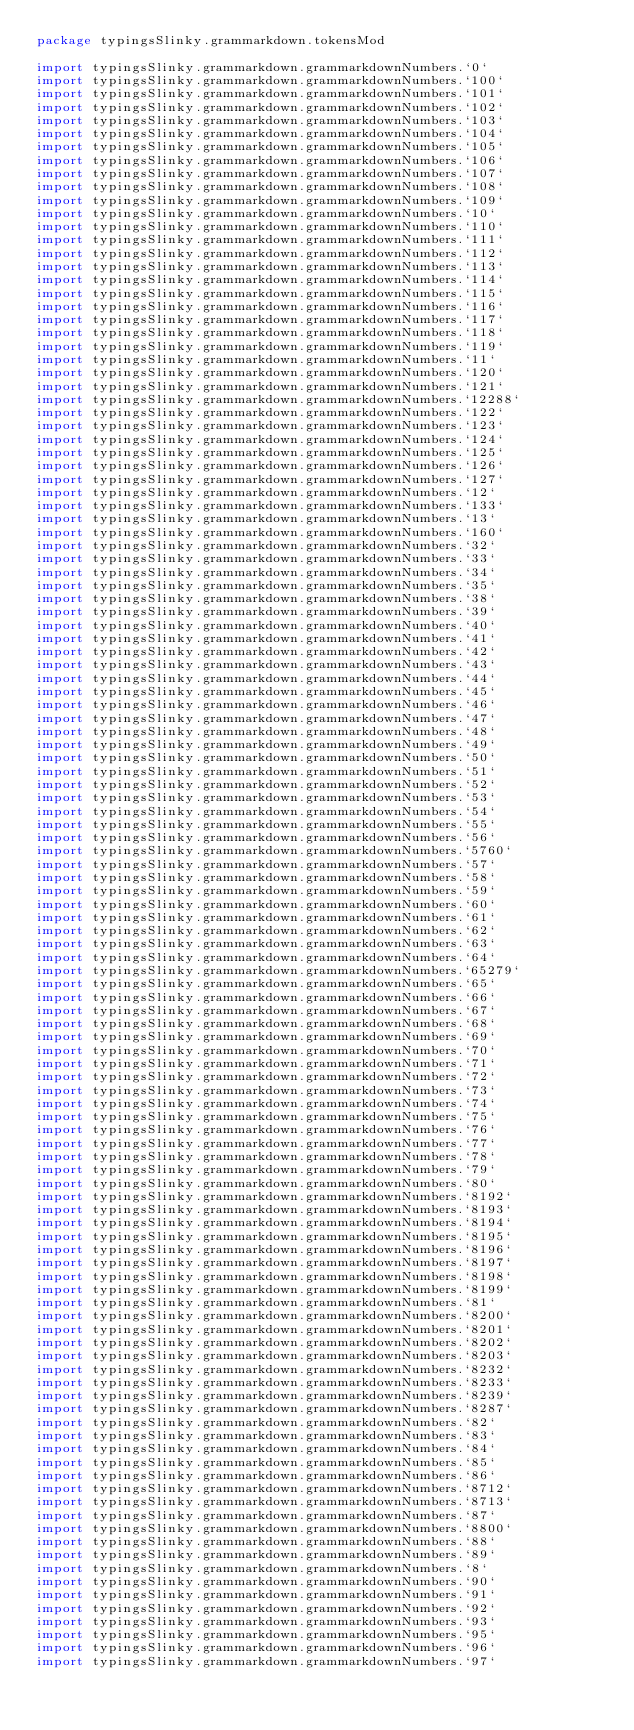<code> <loc_0><loc_0><loc_500><loc_500><_Scala_>package typingsSlinky.grammarkdown.tokensMod

import typingsSlinky.grammarkdown.grammarkdownNumbers.`0`
import typingsSlinky.grammarkdown.grammarkdownNumbers.`100`
import typingsSlinky.grammarkdown.grammarkdownNumbers.`101`
import typingsSlinky.grammarkdown.grammarkdownNumbers.`102`
import typingsSlinky.grammarkdown.grammarkdownNumbers.`103`
import typingsSlinky.grammarkdown.grammarkdownNumbers.`104`
import typingsSlinky.grammarkdown.grammarkdownNumbers.`105`
import typingsSlinky.grammarkdown.grammarkdownNumbers.`106`
import typingsSlinky.grammarkdown.grammarkdownNumbers.`107`
import typingsSlinky.grammarkdown.grammarkdownNumbers.`108`
import typingsSlinky.grammarkdown.grammarkdownNumbers.`109`
import typingsSlinky.grammarkdown.grammarkdownNumbers.`10`
import typingsSlinky.grammarkdown.grammarkdownNumbers.`110`
import typingsSlinky.grammarkdown.grammarkdownNumbers.`111`
import typingsSlinky.grammarkdown.grammarkdownNumbers.`112`
import typingsSlinky.grammarkdown.grammarkdownNumbers.`113`
import typingsSlinky.grammarkdown.grammarkdownNumbers.`114`
import typingsSlinky.grammarkdown.grammarkdownNumbers.`115`
import typingsSlinky.grammarkdown.grammarkdownNumbers.`116`
import typingsSlinky.grammarkdown.grammarkdownNumbers.`117`
import typingsSlinky.grammarkdown.grammarkdownNumbers.`118`
import typingsSlinky.grammarkdown.grammarkdownNumbers.`119`
import typingsSlinky.grammarkdown.grammarkdownNumbers.`11`
import typingsSlinky.grammarkdown.grammarkdownNumbers.`120`
import typingsSlinky.grammarkdown.grammarkdownNumbers.`121`
import typingsSlinky.grammarkdown.grammarkdownNumbers.`12288`
import typingsSlinky.grammarkdown.grammarkdownNumbers.`122`
import typingsSlinky.grammarkdown.grammarkdownNumbers.`123`
import typingsSlinky.grammarkdown.grammarkdownNumbers.`124`
import typingsSlinky.grammarkdown.grammarkdownNumbers.`125`
import typingsSlinky.grammarkdown.grammarkdownNumbers.`126`
import typingsSlinky.grammarkdown.grammarkdownNumbers.`127`
import typingsSlinky.grammarkdown.grammarkdownNumbers.`12`
import typingsSlinky.grammarkdown.grammarkdownNumbers.`133`
import typingsSlinky.grammarkdown.grammarkdownNumbers.`13`
import typingsSlinky.grammarkdown.grammarkdownNumbers.`160`
import typingsSlinky.grammarkdown.grammarkdownNumbers.`32`
import typingsSlinky.grammarkdown.grammarkdownNumbers.`33`
import typingsSlinky.grammarkdown.grammarkdownNumbers.`34`
import typingsSlinky.grammarkdown.grammarkdownNumbers.`35`
import typingsSlinky.grammarkdown.grammarkdownNumbers.`38`
import typingsSlinky.grammarkdown.grammarkdownNumbers.`39`
import typingsSlinky.grammarkdown.grammarkdownNumbers.`40`
import typingsSlinky.grammarkdown.grammarkdownNumbers.`41`
import typingsSlinky.grammarkdown.grammarkdownNumbers.`42`
import typingsSlinky.grammarkdown.grammarkdownNumbers.`43`
import typingsSlinky.grammarkdown.grammarkdownNumbers.`44`
import typingsSlinky.grammarkdown.grammarkdownNumbers.`45`
import typingsSlinky.grammarkdown.grammarkdownNumbers.`46`
import typingsSlinky.grammarkdown.grammarkdownNumbers.`47`
import typingsSlinky.grammarkdown.grammarkdownNumbers.`48`
import typingsSlinky.grammarkdown.grammarkdownNumbers.`49`
import typingsSlinky.grammarkdown.grammarkdownNumbers.`50`
import typingsSlinky.grammarkdown.grammarkdownNumbers.`51`
import typingsSlinky.grammarkdown.grammarkdownNumbers.`52`
import typingsSlinky.grammarkdown.grammarkdownNumbers.`53`
import typingsSlinky.grammarkdown.grammarkdownNumbers.`54`
import typingsSlinky.grammarkdown.grammarkdownNumbers.`55`
import typingsSlinky.grammarkdown.grammarkdownNumbers.`56`
import typingsSlinky.grammarkdown.grammarkdownNumbers.`5760`
import typingsSlinky.grammarkdown.grammarkdownNumbers.`57`
import typingsSlinky.grammarkdown.grammarkdownNumbers.`58`
import typingsSlinky.grammarkdown.grammarkdownNumbers.`59`
import typingsSlinky.grammarkdown.grammarkdownNumbers.`60`
import typingsSlinky.grammarkdown.grammarkdownNumbers.`61`
import typingsSlinky.grammarkdown.grammarkdownNumbers.`62`
import typingsSlinky.grammarkdown.grammarkdownNumbers.`63`
import typingsSlinky.grammarkdown.grammarkdownNumbers.`64`
import typingsSlinky.grammarkdown.grammarkdownNumbers.`65279`
import typingsSlinky.grammarkdown.grammarkdownNumbers.`65`
import typingsSlinky.grammarkdown.grammarkdownNumbers.`66`
import typingsSlinky.grammarkdown.grammarkdownNumbers.`67`
import typingsSlinky.grammarkdown.grammarkdownNumbers.`68`
import typingsSlinky.grammarkdown.grammarkdownNumbers.`69`
import typingsSlinky.grammarkdown.grammarkdownNumbers.`70`
import typingsSlinky.grammarkdown.grammarkdownNumbers.`71`
import typingsSlinky.grammarkdown.grammarkdownNumbers.`72`
import typingsSlinky.grammarkdown.grammarkdownNumbers.`73`
import typingsSlinky.grammarkdown.grammarkdownNumbers.`74`
import typingsSlinky.grammarkdown.grammarkdownNumbers.`75`
import typingsSlinky.grammarkdown.grammarkdownNumbers.`76`
import typingsSlinky.grammarkdown.grammarkdownNumbers.`77`
import typingsSlinky.grammarkdown.grammarkdownNumbers.`78`
import typingsSlinky.grammarkdown.grammarkdownNumbers.`79`
import typingsSlinky.grammarkdown.grammarkdownNumbers.`80`
import typingsSlinky.grammarkdown.grammarkdownNumbers.`8192`
import typingsSlinky.grammarkdown.grammarkdownNumbers.`8193`
import typingsSlinky.grammarkdown.grammarkdownNumbers.`8194`
import typingsSlinky.grammarkdown.grammarkdownNumbers.`8195`
import typingsSlinky.grammarkdown.grammarkdownNumbers.`8196`
import typingsSlinky.grammarkdown.grammarkdownNumbers.`8197`
import typingsSlinky.grammarkdown.grammarkdownNumbers.`8198`
import typingsSlinky.grammarkdown.grammarkdownNumbers.`8199`
import typingsSlinky.grammarkdown.grammarkdownNumbers.`81`
import typingsSlinky.grammarkdown.grammarkdownNumbers.`8200`
import typingsSlinky.grammarkdown.grammarkdownNumbers.`8201`
import typingsSlinky.grammarkdown.grammarkdownNumbers.`8202`
import typingsSlinky.grammarkdown.grammarkdownNumbers.`8203`
import typingsSlinky.grammarkdown.grammarkdownNumbers.`8232`
import typingsSlinky.grammarkdown.grammarkdownNumbers.`8233`
import typingsSlinky.grammarkdown.grammarkdownNumbers.`8239`
import typingsSlinky.grammarkdown.grammarkdownNumbers.`8287`
import typingsSlinky.grammarkdown.grammarkdownNumbers.`82`
import typingsSlinky.grammarkdown.grammarkdownNumbers.`83`
import typingsSlinky.grammarkdown.grammarkdownNumbers.`84`
import typingsSlinky.grammarkdown.grammarkdownNumbers.`85`
import typingsSlinky.grammarkdown.grammarkdownNumbers.`86`
import typingsSlinky.grammarkdown.grammarkdownNumbers.`8712`
import typingsSlinky.grammarkdown.grammarkdownNumbers.`8713`
import typingsSlinky.grammarkdown.grammarkdownNumbers.`87`
import typingsSlinky.grammarkdown.grammarkdownNumbers.`8800`
import typingsSlinky.grammarkdown.grammarkdownNumbers.`88`
import typingsSlinky.grammarkdown.grammarkdownNumbers.`89`
import typingsSlinky.grammarkdown.grammarkdownNumbers.`8`
import typingsSlinky.grammarkdown.grammarkdownNumbers.`90`
import typingsSlinky.grammarkdown.grammarkdownNumbers.`91`
import typingsSlinky.grammarkdown.grammarkdownNumbers.`92`
import typingsSlinky.grammarkdown.grammarkdownNumbers.`93`
import typingsSlinky.grammarkdown.grammarkdownNumbers.`95`
import typingsSlinky.grammarkdown.grammarkdownNumbers.`96`
import typingsSlinky.grammarkdown.grammarkdownNumbers.`97`</code> 